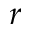Convert formula to latex. <formula><loc_0><loc_0><loc_500><loc_500>r</formula> 